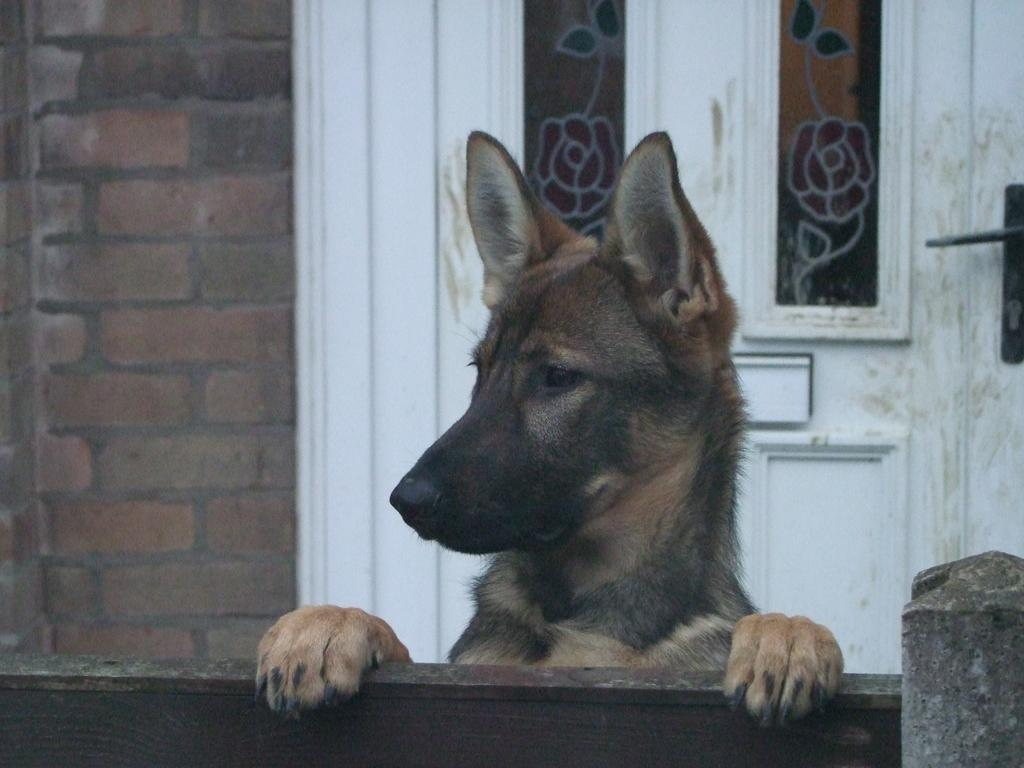What type of animal is in the image? There is a dog in the image. What colors can be seen on the dog? The dog is black and brown in color. What breed of dog is it? The dog is a German shepherd. What can be seen in the background of the image? There is a wall and a white color door in the background of the image. What type of expert advice can be seen in the image? There is no expert advice present in the image; it features a dog and a background with a wall and a white door. What texture can be felt on the dog's fur in the image? The texture of the dog's fur cannot be determined from the image alone, as it is a two-dimensional representation. 